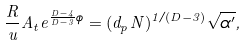Convert formula to latex. <formula><loc_0><loc_0><loc_500><loc_500>\frac { R } { u } A _ { t } e ^ { \frac { D - 4 } { D - 3 } \phi } = ( d _ { p } N ) ^ { 1 / ( D - 3 ) } \sqrt { \alpha ^ { \prime } } ,</formula> 